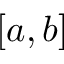Convert formula to latex. <formula><loc_0><loc_0><loc_500><loc_500>[ a , b ]</formula> 